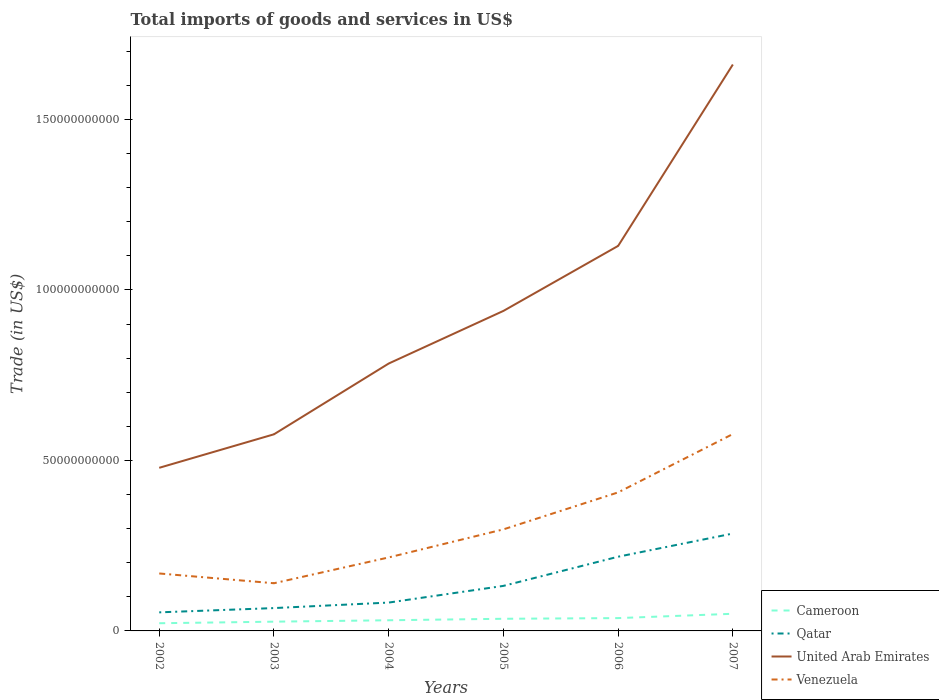How many different coloured lines are there?
Your response must be concise. 4. Is the number of lines equal to the number of legend labels?
Provide a succinct answer. Yes. Across all years, what is the maximum total imports of goods and services in Cameroon?
Your response must be concise. 2.25e+09. In which year was the total imports of goods and services in Venezuela maximum?
Offer a very short reply. 2003. What is the total total imports of goods and services in United Arab Emirates in the graph?
Your answer should be very brief. -1.91e+1. What is the difference between the highest and the second highest total imports of goods and services in Venezuela?
Provide a short and direct response. 4.38e+1. How many lines are there?
Offer a very short reply. 4. What is the difference between two consecutive major ticks on the Y-axis?
Ensure brevity in your answer.  5.00e+1. Are the values on the major ticks of Y-axis written in scientific E-notation?
Keep it short and to the point. No. Does the graph contain any zero values?
Provide a succinct answer. No. Does the graph contain grids?
Provide a succinct answer. No. How are the legend labels stacked?
Your answer should be very brief. Vertical. What is the title of the graph?
Offer a terse response. Total imports of goods and services in US$. Does "Korea (Democratic)" appear as one of the legend labels in the graph?
Ensure brevity in your answer.  No. What is the label or title of the X-axis?
Ensure brevity in your answer.  Years. What is the label or title of the Y-axis?
Offer a terse response. Trade (in US$). What is the Trade (in US$) of Cameroon in 2002?
Ensure brevity in your answer.  2.25e+09. What is the Trade (in US$) of Qatar in 2002?
Give a very brief answer. 5.45e+09. What is the Trade (in US$) in United Arab Emirates in 2002?
Give a very brief answer. 4.78e+1. What is the Trade (in US$) in Venezuela in 2002?
Your answer should be compact. 1.69e+1. What is the Trade (in US$) of Cameroon in 2003?
Offer a very short reply. 2.71e+09. What is the Trade (in US$) in Qatar in 2003?
Offer a very short reply. 6.70e+09. What is the Trade (in US$) in United Arab Emirates in 2003?
Your answer should be very brief. 5.77e+1. What is the Trade (in US$) of Venezuela in 2003?
Offer a terse response. 1.40e+1. What is the Trade (in US$) in Cameroon in 2004?
Your response must be concise. 3.13e+09. What is the Trade (in US$) of Qatar in 2004?
Provide a succinct answer. 8.32e+09. What is the Trade (in US$) of United Arab Emirates in 2004?
Ensure brevity in your answer.  7.84e+1. What is the Trade (in US$) of Venezuela in 2004?
Your answer should be very brief. 2.16e+1. What is the Trade (in US$) of Cameroon in 2005?
Offer a terse response. 3.56e+09. What is the Trade (in US$) of Qatar in 2005?
Keep it short and to the point. 1.32e+1. What is the Trade (in US$) in United Arab Emirates in 2005?
Make the answer very short. 9.39e+1. What is the Trade (in US$) of Venezuela in 2005?
Your answer should be compact. 2.98e+1. What is the Trade (in US$) of Cameroon in 2006?
Ensure brevity in your answer.  3.76e+09. What is the Trade (in US$) in Qatar in 2006?
Ensure brevity in your answer.  2.18e+1. What is the Trade (in US$) in United Arab Emirates in 2006?
Provide a succinct answer. 1.13e+11. What is the Trade (in US$) of Venezuela in 2006?
Provide a short and direct response. 4.06e+1. What is the Trade (in US$) of Cameroon in 2007?
Ensure brevity in your answer.  5.03e+09. What is the Trade (in US$) of Qatar in 2007?
Keep it short and to the point. 2.86e+1. What is the Trade (in US$) in United Arab Emirates in 2007?
Offer a terse response. 1.66e+11. What is the Trade (in US$) of Venezuela in 2007?
Your response must be concise. 5.77e+1. Across all years, what is the maximum Trade (in US$) in Cameroon?
Make the answer very short. 5.03e+09. Across all years, what is the maximum Trade (in US$) in Qatar?
Provide a short and direct response. 2.86e+1. Across all years, what is the maximum Trade (in US$) of United Arab Emirates?
Make the answer very short. 1.66e+11. Across all years, what is the maximum Trade (in US$) of Venezuela?
Your response must be concise. 5.77e+1. Across all years, what is the minimum Trade (in US$) of Cameroon?
Ensure brevity in your answer.  2.25e+09. Across all years, what is the minimum Trade (in US$) of Qatar?
Your answer should be compact. 5.45e+09. Across all years, what is the minimum Trade (in US$) in United Arab Emirates?
Keep it short and to the point. 4.78e+1. Across all years, what is the minimum Trade (in US$) of Venezuela?
Provide a short and direct response. 1.40e+1. What is the total Trade (in US$) in Cameroon in the graph?
Ensure brevity in your answer.  2.04e+1. What is the total Trade (in US$) of Qatar in the graph?
Keep it short and to the point. 8.40e+1. What is the total Trade (in US$) in United Arab Emirates in the graph?
Provide a short and direct response. 5.57e+11. What is the total Trade (in US$) of Venezuela in the graph?
Keep it short and to the point. 1.81e+11. What is the difference between the Trade (in US$) of Cameroon in 2002 and that in 2003?
Ensure brevity in your answer.  -4.58e+08. What is the difference between the Trade (in US$) of Qatar in 2002 and that in 2003?
Your answer should be compact. -1.25e+09. What is the difference between the Trade (in US$) of United Arab Emirates in 2002 and that in 2003?
Provide a succinct answer. -9.82e+09. What is the difference between the Trade (in US$) of Venezuela in 2002 and that in 2003?
Your answer should be very brief. 2.87e+09. What is the difference between the Trade (in US$) in Cameroon in 2002 and that in 2004?
Offer a terse response. -8.74e+08. What is the difference between the Trade (in US$) of Qatar in 2002 and that in 2004?
Provide a short and direct response. -2.87e+09. What is the difference between the Trade (in US$) of United Arab Emirates in 2002 and that in 2004?
Make the answer very short. -3.06e+1. What is the difference between the Trade (in US$) in Venezuela in 2002 and that in 2004?
Your answer should be compact. -4.70e+09. What is the difference between the Trade (in US$) of Cameroon in 2002 and that in 2005?
Offer a very short reply. -1.31e+09. What is the difference between the Trade (in US$) of Qatar in 2002 and that in 2005?
Make the answer very short. -7.76e+09. What is the difference between the Trade (in US$) of United Arab Emirates in 2002 and that in 2005?
Your response must be concise. -4.60e+1. What is the difference between the Trade (in US$) of Venezuela in 2002 and that in 2005?
Your answer should be very brief. -1.29e+1. What is the difference between the Trade (in US$) in Cameroon in 2002 and that in 2006?
Make the answer very short. -1.51e+09. What is the difference between the Trade (in US$) of Qatar in 2002 and that in 2006?
Your answer should be compact. -1.63e+1. What is the difference between the Trade (in US$) of United Arab Emirates in 2002 and that in 2006?
Offer a very short reply. -6.51e+1. What is the difference between the Trade (in US$) in Venezuela in 2002 and that in 2006?
Offer a terse response. -2.38e+1. What is the difference between the Trade (in US$) of Cameroon in 2002 and that in 2007?
Your answer should be very brief. -2.77e+09. What is the difference between the Trade (in US$) of Qatar in 2002 and that in 2007?
Offer a very short reply. -2.31e+1. What is the difference between the Trade (in US$) in United Arab Emirates in 2002 and that in 2007?
Give a very brief answer. -1.18e+11. What is the difference between the Trade (in US$) in Venezuela in 2002 and that in 2007?
Provide a short and direct response. -4.09e+1. What is the difference between the Trade (in US$) in Cameroon in 2003 and that in 2004?
Give a very brief answer. -4.16e+08. What is the difference between the Trade (in US$) in Qatar in 2003 and that in 2004?
Keep it short and to the point. -1.62e+09. What is the difference between the Trade (in US$) in United Arab Emirates in 2003 and that in 2004?
Your answer should be compact. -2.08e+1. What is the difference between the Trade (in US$) in Venezuela in 2003 and that in 2004?
Your answer should be compact. -7.57e+09. What is the difference between the Trade (in US$) of Cameroon in 2003 and that in 2005?
Make the answer very short. -8.49e+08. What is the difference between the Trade (in US$) of Qatar in 2003 and that in 2005?
Give a very brief answer. -6.51e+09. What is the difference between the Trade (in US$) of United Arab Emirates in 2003 and that in 2005?
Ensure brevity in your answer.  -3.62e+1. What is the difference between the Trade (in US$) in Venezuela in 2003 and that in 2005?
Make the answer very short. -1.58e+1. What is the difference between the Trade (in US$) of Cameroon in 2003 and that in 2006?
Keep it short and to the point. -1.05e+09. What is the difference between the Trade (in US$) of Qatar in 2003 and that in 2006?
Provide a short and direct response. -1.51e+1. What is the difference between the Trade (in US$) in United Arab Emirates in 2003 and that in 2006?
Ensure brevity in your answer.  -5.53e+1. What is the difference between the Trade (in US$) in Venezuela in 2003 and that in 2006?
Keep it short and to the point. -2.67e+1. What is the difference between the Trade (in US$) in Cameroon in 2003 and that in 2007?
Provide a short and direct response. -2.32e+09. What is the difference between the Trade (in US$) in Qatar in 2003 and that in 2007?
Keep it short and to the point. -2.19e+1. What is the difference between the Trade (in US$) in United Arab Emirates in 2003 and that in 2007?
Ensure brevity in your answer.  -1.08e+11. What is the difference between the Trade (in US$) of Venezuela in 2003 and that in 2007?
Your response must be concise. -4.38e+1. What is the difference between the Trade (in US$) of Cameroon in 2004 and that in 2005?
Your answer should be compact. -4.33e+08. What is the difference between the Trade (in US$) in Qatar in 2004 and that in 2005?
Make the answer very short. -4.89e+09. What is the difference between the Trade (in US$) in United Arab Emirates in 2004 and that in 2005?
Your answer should be compact. -1.54e+1. What is the difference between the Trade (in US$) of Venezuela in 2004 and that in 2005?
Your answer should be very brief. -8.23e+09. What is the difference between the Trade (in US$) in Cameroon in 2004 and that in 2006?
Keep it short and to the point. -6.33e+08. What is the difference between the Trade (in US$) in Qatar in 2004 and that in 2006?
Offer a very short reply. -1.35e+1. What is the difference between the Trade (in US$) in United Arab Emirates in 2004 and that in 2006?
Make the answer very short. -3.45e+1. What is the difference between the Trade (in US$) of Venezuela in 2004 and that in 2006?
Make the answer very short. -1.91e+1. What is the difference between the Trade (in US$) in Cameroon in 2004 and that in 2007?
Offer a terse response. -1.90e+09. What is the difference between the Trade (in US$) in Qatar in 2004 and that in 2007?
Keep it short and to the point. -2.03e+1. What is the difference between the Trade (in US$) of United Arab Emirates in 2004 and that in 2007?
Keep it short and to the point. -8.77e+1. What is the difference between the Trade (in US$) of Venezuela in 2004 and that in 2007?
Your answer should be very brief. -3.62e+1. What is the difference between the Trade (in US$) in Cameroon in 2005 and that in 2006?
Provide a short and direct response. -2.00e+08. What is the difference between the Trade (in US$) in Qatar in 2005 and that in 2006?
Your answer should be very brief. -8.56e+09. What is the difference between the Trade (in US$) in United Arab Emirates in 2005 and that in 2006?
Make the answer very short. -1.91e+1. What is the difference between the Trade (in US$) in Venezuela in 2005 and that in 2006?
Your answer should be very brief. -1.09e+1. What is the difference between the Trade (in US$) of Cameroon in 2005 and that in 2007?
Your answer should be very brief. -1.47e+09. What is the difference between the Trade (in US$) in Qatar in 2005 and that in 2007?
Offer a very short reply. -1.54e+1. What is the difference between the Trade (in US$) of United Arab Emirates in 2005 and that in 2007?
Your response must be concise. -7.23e+1. What is the difference between the Trade (in US$) of Venezuela in 2005 and that in 2007?
Offer a terse response. -2.80e+1. What is the difference between the Trade (in US$) of Cameroon in 2006 and that in 2007?
Provide a succinct answer. -1.27e+09. What is the difference between the Trade (in US$) in Qatar in 2006 and that in 2007?
Give a very brief answer. -6.80e+09. What is the difference between the Trade (in US$) in United Arab Emirates in 2006 and that in 2007?
Offer a very short reply. -5.32e+1. What is the difference between the Trade (in US$) in Venezuela in 2006 and that in 2007?
Your answer should be very brief. -1.71e+1. What is the difference between the Trade (in US$) of Cameroon in 2002 and the Trade (in US$) of Qatar in 2003?
Ensure brevity in your answer.  -4.45e+09. What is the difference between the Trade (in US$) in Cameroon in 2002 and the Trade (in US$) in United Arab Emirates in 2003?
Offer a terse response. -5.54e+1. What is the difference between the Trade (in US$) of Cameroon in 2002 and the Trade (in US$) of Venezuela in 2003?
Give a very brief answer. -1.17e+1. What is the difference between the Trade (in US$) in Qatar in 2002 and the Trade (in US$) in United Arab Emirates in 2003?
Offer a very short reply. -5.22e+1. What is the difference between the Trade (in US$) in Qatar in 2002 and the Trade (in US$) in Venezuela in 2003?
Provide a succinct answer. -8.54e+09. What is the difference between the Trade (in US$) of United Arab Emirates in 2002 and the Trade (in US$) of Venezuela in 2003?
Your answer should be very brief. 3.39e+1. What is the difference between the Trade (in US$) in Cameroon in 2002 and the Trade (in US$) in Qatar in 2004?
Provide a succinct answer. -6.06e+09. What is the difference between the Trade (in US$) in Cameroon in 2002 and the Trade (in US$) in United Arab Emirates in 2004?
Offer a terse response. -7.62e+1. What is the difference between the Trade (in US$) in Cameroon in 2002 and the Trade (in US$) in Venezuela in 2004?
Give a very brief answer. -1.93e+1. What is the difference between the Trade (in US$) in Qatar in 2002 and the Trade (in US$) in United Arab Emirates in 2004?
Your response must be concise. -7.30e+1. What is the difference between the Trade (in US$) in Qatar in 2002 and the Trade (in US$) in Venezuela in 2004?
Ensure brevity in your answer.  -1.61e+1. What is the difference between the Trade (in US$) in United Arab Emirates in 2002 and the Trade (in US$) in Venezuela in 2004?
Provide a short and direct response. 2.63e+1. What is the difference between the Trade (in US$) of Cameroon in 2002 and the Trade (in US$) of Qatar in 2005?
Make the answer very short. -1.10e+1. What is the difference between the Trade (in US$) of Cameroon in 2002 and the Trade (in US$) of United Arab Emirates in 2005?
Give a very brief answer. -9.16e+1. What is the difference between the Trade (in US$) in Cameroon in 2002 and the Trade (in US$) in Venezuela in 2005?
Keep it short and to the point. -2.75e+1. What is the difference between the Trade (in US$) in Qatar in 2002 and the Trade (in US$) in United Arab Emirates in 2005?
Make the answer very short. -8.84e+1. What is the difference between the Trade (in US$) in Qatar in 2002 and the Trade (in US$) in Venezuela in 2005?
Provide a short and direct response. -2.43e+1. What is the difference between the Trade (in US$) in United Arab Emirates in 2002 and the Trade (in US$) in Venezuela in 2005?
Offer a terse response. 1.81e+1. What is the difference between the Trade (in US$) of Cameroon in 2002 and the Trade (in US$) of Qatar in 2006?
Your response must be concise. -1.95e+1. What is the difference between the Trade (in US$) in Cameroon in 2002 and the Trade (in US$) in United Arab Emirates in 2006?
Offer a terse response. -1.11e+11. What is the difference between the Trade (in US$) of Cameroon in 2002 and the Trade (in US$) of Venezuela in 2006?
Your answer should be compact. -3.84e+1. What is the difference between the Trade (in US$) of Qatar in 2002 and the Trade (in US$) of United Arab Emirates in 2006?
Ensure brevity in your answer.  -1.07e+11. What is the difference between the Trade (in US$) of Qatar in 2002 and the Trade (in US$) of Venezuela in 2006?
Provide a succinct answer. -3.52e+1. What is the difference between the Trade (in US$) of United Arab Emirates in 2002 and the Trade (in US$) of Venezuela in 2006?
Offer a very short reply. 7.21e+09. What is the difference between the Trade (in US$) in Cameroon in 2002 and the Trade (in US$) in Qatar in 2007?
Offer a very short reply. -2.63e+1. What is the difference between the Trade (in US$) of Cameroon in 2002 and the Trade (in US$) of United Arab Emirates in 2007?
Your answer should be very brief. -1.64e+11. What is the difference between the Trade (in US$) of Cameroon in 2002 and the Trade (in US$) of Venezuela in 2007?
Offer a terse response. -5.55e+1. What is the difference between the Trade (in US$) of Qatar in 2002 and the Trade (in US$) of United Arab Emirates in 2007?
Make the answer very short. -1.61e+11. What is the difference between the Trade (in US$) of Qatar in 2002 and the Trade (in US$) of Venezuela in 2007?
Your answer should be very brief. -5.23e+1. What is the difference between the Trade (in US$) in United Arab Emirates in 2002 and the Trade (in US$) in Venezuela in 2007?
Ensure brevity in your answer.  -9.90e+09. What is the difference between the Trade (in US$) in Cameroon in 2003 and the Trade (in US$) in Qatar in 2004?
Keep it short and to the point. -5.60e+09. What is the difference between the Trade (in US$) in Cameroon in 2003 and the Trade (in US$) in United Arab Emirates in 2004?
Your answer should be very brief. -7.57e+1. What is the difference between the Trade (in US$) in Cameroon in 2003 and the Trade (in US$) in Venezuela in 2004?
Ensure brevity in your answer.  -1.88e+1. What is the difference between the Trade (in US$) of Qatar in 2003 and the Trade (in US$) of United Arab Emirates in 2004?
Provide a succinct answer. -7.17e+1. What is the difference between the Trade (in US$) in Qatar in 2003 and the Trade (in US$) in Venezuela in 2004?
Give a very brief answer. -1.49e+1. What is the difference between the Trade (in US$) of United Arab Emirates in 2003 and the Trade (in US$) of Venezuela in 2004?
Ensure brevity in your answer.  3.61e+1. What is the difference between the Trade (in US$) of Cameroon in 2003 and the Trade (in US$) of Qatar in 2005?
Your response must be concise. -1.05e+1. What is the difference between the Trade (in US$) in Cameroon in 2003 and the Trade (in US$) in United Arab Emirates in 2005?
Offer a very short reply. -9.12e+1. What is the difference between the Trade (in US$) of Cameroon in 2003 and the Trade (in US$) of Venezuela in 2005?
Keep it short and to the point. -2.71e+1. What is the difference between the Trade (in US$) of Qatar in 2003 and the Trade (in US$) of United Arab Emirates in 2005?
Your answer should be very brief. -8.72e+1. What is the difference between the Trade (in US$) in Qatar in 2003 and the Trade (in US$) in Venezuela in 2005?
Your answer should be compact. -2.31e+1. What is the difference between the Trade (in US$) in United Arab Emirates in 2003 and the Trade (in US$) in Venezuela in 2005?
Make the answer very short. 2.79e+1. What is the difference between the Trade (in US$) of Cameroon in 2003 and the Trade (in US$) of Qatar in 2006?
Make the answer very short. -1.91e+1. What is the difference between the Trade (in US$) in Cameroon in 2003 and the Trade (in US$) in United Arab Emirates in 2006?
Give a very brief answer. -1.10e+11. What is the difference between the Trade (in US$) of Cameroon in 2003 and the Trade (in US$) of Venezuela in 2006?
Your answer should be very brief. -3.79e+1. What is the difference between the Trade (in US$) of Qatar in 2003 and the Trade (in US$) of United Arab Emirates in 2006?
Make the answer very short. -1.06e+11. What is the difference between the Trade (in US$) of Qatar in 2003 and the Trade (in US$) of Venezuela in 2006?
Offer a very short reply. -3.39e+1. What is the difference between the Trade (in US$) of United Arab Emirates in 2003 and the Trade (in US$) of Venezuela in 2006?
Make the answer very short. 1.70e+1. What is the difference between the Trade (in US$) in Cameroon in 2003 and the Trade (in US$) in Qatar in 2007?
Your answer should be compact. -2.59e+1. What is the difference between the Trade (in US$) of Cameroon in 2003 and the Trade (in US$) of United Arab Emirates in 2007?
Provide a short and direct response. -1.63e+11. What is the difference between the Trade (in US$) in Cameroon in 2003 and the Trade (in US$) in Venezuela in 2007?
Your answer should be very brief. -5.50e+1. What is the difference between the Trade (in US$) in Qatar in 2003 and the Trade (in US$) in United Arab Emirates in 2007?
Your answer should be compact. -1.59e+11. What is the difference between the Trade (in US$) of Qatar in 2003 and the Trade (in US$) of Venezuela in 2007?
Provide a succinct answer. -5.10e+1. What is the difference between the Trade (in US$) of United Arab Emirates in 2003 and the Trade (in US$) of Venezuela in 2007?
Keep it short and to the point. -8.09e+07. What is the difference between the Trade (in US$) in Cameroon in 2004 and the Trade (in US$) in Qatar in 2005?
Your answer should be very brief. -1.01e+1. What is the difference between the Trade (in US$) of Cameroon in 2004 and the Trade (in US$) of United Arab Emirates in 2005?
Your answer should be compact. -9.07e+1. What is the difference between the Trade (in US$) in Cameroon in 2004 and the Trade (in US$) in Venezuela in 2005?
Offer a very short reply. -2.67e+1. What is the difference between the Trade (in US$) of Qatar in 2004 and the Trade (in US$) of United Arab Emirates in 2005?
Make the answer very short. -8.55e+1. What is the difference between the Trade (in US$) of Qatar in 2004 and the Trade (in US$) of Venezuela in 2005?
Your answer should be very brief. -2.15e+1. What is the difference between the Trade (in US$) of United Arab Emirates in 2004 and the Trade (in US$) of Venezuela in 2005?
Your answer should be very brief. 4.86e+1. What is the difference between the Trade (in US$) of Cameroon in 2004 and the Trade (in US$) of Qatar in 2006?
Give a very brief answer. -1.86e+1. What is the difference between the Trade (in US$) of Cameroon in 2004 and the Trade (in US$) of United Arab Emirates in 2006?
Provide a succinct answer. -1.10e+11. What is the difference between the Trade (in US$) of Cameroon in 2004 and the Trade (in US$) of Venezuela in 2006?
Make the answer very short. -3.75e+1. What is the difference between the Trade (in US$) of Qatar in 2004 and the Trade (in US$) of United Arab Emirates in 2006?
Offer a very short reply. -1.05e+11. What is the difference between the Trade (in US$) in Qatar in 2004 and the Trade (in US$) in Venezuela in 2006?
Your answer should be very brief. -3.23e+1. What is the difference between the Trade (in US$) in United Arab Emirates in 2004 and the Trade (in US$) in Venezuela in 2006?
Offer a terse response. 3.78e+1. What is the difference between the Trade (in US$) of Cameroon in 2004 and the Trade (in US$) of Qatar in 2007?
Ensure brevity in your answer.  -2.54e+1. What is the difference between the Trade (in US$) in Cameroon in 2004 and the Trade (in US$) in United Arab Emirates in 2007?
Provide a succinct answer. -1.63e+11. What is the difference between the Trade (in US$) of Cameroon in 2004 and the Trade (in US$) of Venezuela in 2007?
Ensure brevity in your answer.  -5.46e+1. What is the difference between the Trade (in US$) in Qatar in 2004 and the Trade (in US$) in United Arab Emirates in 2007?
Your answer should be very brief. -1.58e+11. What is the difference between the Trade (in US$) in Qatar in 2004 and the Trade (in US$) in Venezuela in 2007?
Ensure brevity in your answer.  -4.94e+1. What is the difference between the Trade (in US$) in United Arab Emirates in 2004 and the Trade (in US$) in Venezuela in 2007?
Keep it short and to the point. 2.07e+1. What is the difference between the Trade (in US$) of Cameroon in 2005 and the Trade (in US$) of Qatar in 2006?
Give a very brief answer. -1.82e+1. What is the difference between the Trade (in US$) in Cameroon in 2005 and the Trade (in US$) in United Arab Emirates in 2006?
Make the answer very short. -1.09e+11. What is the difference between the Trade (in US$) of Cameroon in 2005 and the Trade (in US$) of Venezuela in 2006?
Provide a short and direct response. -3.71e+1. What is the difference between the Trade (in US$) in Qatar in 2005 and the Trade (in US$) in United Arab Emirates in 2006?
Keep it short and to the point. -9.97e+1. What is the difference between the Trade (in US$) of Qatar in 2005 and the Trade (in US$) of Venezuela in 2006?
Make the answer very short. -2.74e+1. What is the difference between the Trade (in US$) of United Arab Emirates in 2005 and the Trade (in US$) of Venezuela in 2006?
Ensure brevity in your answer.  5.32e+1. What is the difference between the Trade (in US$) of Cameroon in 2005 and the Trade (in US$) of Qatar in 2007?
Offer a terse response. -2.50e+1. What is the difference between the Trade (in US$) in Cameroon in 2005 and the Trade (in US$) in United Arab Emirates in 2007?
Your answer should be compact. -1.63e+11. What is the difference between the Trade (in US$) of Cameroon in 2005 and the Trade (in US$) of Venezuela in 2007?
Offer a very short reply. -5.42e+1. What is the difference between the Trade (in US$) in Qatar in 2005 and the Trade (in US$) in United Arab Emirates in 2007?
Offer a terse response. -1.53e+11. What is the difference between the Trade (in US$) in Qatar in 2005 and the Trade (in US$) in Venezuela in 2007?
Ensure brevity in your answer.  -4.45e+1. What is the difference between the Trade (in US$) of United Arab Emirates in 2005 and the Trade (in US$) of Venezuela in 2007?
Keep it short and to the point. 3.61e+1. What is the difference between the Trade (in US$) in Cameroon in 2006 and the Trade (in US$) in Qatar in 2007?
Ensure brevity in your answer.  -2.48e+1. What is the difference between the Trade (in US$) of Cameroon in 2006 and the Trade (in US$) of United Arab Emirates in 2007?
Give a very brief answer. -1.62e+11. What is the difference between the Trade (in US$) in Cameroon in 2006 and the Trade (in US$) in Venezuela in 2007?
Give a very brief answer. -5.40e+1. What is the difference between the Trade (in US$) in Qatar in 2006 and the Trade (in US$) in United Arab Emirates in 2007?
Give a very brief answer. -1.44e+11. What is the difference between the Trade (in US$) of Qatar in 2006 and the Trade (in US$) of Venezuela in 2007?
Your response must be concise. -3.60e+1. What is the difference between the Trade (in US$) in United Arab Emirates in 2006 and the Trade (in US$) in Venezuela in 2007?
Keep it short and to the point. 5.52e+1. What is the average Trade (in US$) in Cameroon per year?
Keep it short and to the point. 3.41e+09. What is the average Trade (in US$) of Qatar per year?
Your response must be concise. 1.40e+1. What is the average Trade (in US$) in United Arab Emirates per year?
Your response must be concise. 9.28e+1. What is the average Trade (in US$) in Venezuela per year?
Your answer should be compact. 3.01e+1. In the year 2002, what is the difference between the Trade (in US$) in Cameroon and Trade (in US$) in Qatar?
Provide a short and direct response. -3.19e+09. In the year 2002, what is the difference between the Trade (in US$) of Cameroon and Trade (in US$) of United Arab Emirates?
Keep it short and to the point. -4.56e+1. In the year 2002, what is the difference between the Trade (in US$) of Cameroon and Trade (in US$) of Venezuela?
Offer a terse response. -1.46e+1. In the year 2002, what is the difference between the Trade (in US$) in Qatar and Trade (in US$) in United Arab Emirates?
Give a very brief answer. -4.24e+1. In the year 2002, what is the difference between the Trade (in US$) of Qatar and Trade (in US$) of Venezuela?
Make the answer very short. -1.14e+1. In the year 2002, what is the difference between the Trade (in US$) in United Arab Emirates and Trade (in US$) in Venezuela?
Make the answer very short. 3.10e+1. In the year 2003, what is the difference between the Trade (in US$) of Cameroon and Trade (in US$) of Qatar?
Your response must be concise. -3.99e+09. In the year 2003, what is the difference between the Trade (in US$) in Cameroon and Trade (in US$) in United Arab Emirates?
Provide a succinct answer. -5.50e+1. In the year 2003, what is the difference between the Trade (in US$) of Cameroon and Trade (in US$) of Venezuela?
Offer a terse response. -1.13e+1. In the year 2003, what is the difference between the Trade (in US$) in Qatar and Trade (in US$) in United Arab Emirates?
Provide a short and direct response. -5.10e+1. In the year 2003, what is the difference between the Trade (in US$) of Qatar and Trade (in US$) of Venezuela?
Offer a very short reply. -7.29e+09. In the year 2003, what is the difference between the Trade (in US$) in United Arab Emirates and Trade (in US$) in Venezuela?
Ensure brevity in your answer.  4.37e+1. In the year 2004, what is the difference between the Trade (in US$) of Cameroon and Trade (in US$) of Qatar?
Offer a very short reply. -5.19e+09. In the year 2004, what is the difference between the Trade (in US$) of Cameroon and Trade (in US$) of United Arab Emirates?
Provide a short and direct response. -7.53e+1. In the year 2004, what is the difference between the Trade (in US$) of Cameroon and Trade (in US$) of Venezuela?
Offer a very short reply. -1.84e+1. In the year 2004, what is the difference between the Trade (in US$) in Qatar and Trade (in US$) in United Arab Emirates?
Give a very brief answer. -7.01e+1. In the year 2004, what is the difference between the Trade (in US$) in Qatar and Trade (in US$) in Venezuela?
Offer a very short reply. -1.32e+1. In the year 2004, what is the difference between the Trade (in US$) in United Arab Emirates and Trade (in US$) in Venezuela?
Provide a succinct answer. 5.69e+1. In the year 2005, what is the difference between the Trade (in US$) in Cameroon and Trade (in US$) in Qatar?
Give a very brief answer. -9.65e+09. In the year 2005, what is the difference between the Trade (in US$) of Cameroon and Trade (in US$) of United Arab Emirates?
Ensure brevity in your answer.  -9.03e+1. In the year 2005, what is the difference between the Trade (in US$) in Cameroon and Trade (in US$) in Venezuela?
Provide a short and direct response. -2.62e+1. In the year 2005, what is the difference between the Trade (in US$) of Qatar and Trade (in US$) of United Arab Emirates?
Your answer should be very brief. -8.07e+1. In the year 2005, what is the difference between the Trade (in US$) of Qatar and Trade (in US$) of Venezuela?
Give a very brief answer. -1.66e+1. In the year 2005, what is the difference between the Trade (in US$) of United Arab Emirates and Trade (in US$) of Venezuela?
Provide a short and direct response. 6.41e+1. In the year 2006, what is the difference between the Trade (in US$) in Cameroon and Trade (in US$) in Qatar?
Provide a short and direct response. -1.80e+1. In the year 2006, what is the difference between the Trade (in US$) of Cameroon and Trade (in US$) of United Arab Emirates?
Keep it short and to the point. -1.09e+11. In the year 2006, what is the difference between the Trade (in US$) in Cameroon and Trade (in US$) in Venezuela?
Offer a terse response. -3.69e+1. In the year 2006, what is the difference between the Trade (in US$) in Qatar and Trade (in US$) in United Arab Emirates?
Your answer should be very brief. -9.12e+1. In the year 2006, what is the difference between the Trade (in US$) of Qatar and Trade (in US$) of Venezuela?
Give a very brief answer. -1.89e+1. In the year 2006, what is the difference between the Trade (in US$) in United Arab Emirates and Trade (in US$) in Venezuela?
Keep it short and to the point. 7.23e+1. In the year 2007, what is the difference between the Trade (in US$) in Cameroon and Trade (in US$) in Qatar?
Offer a terse response. -2.35e+1. In the year 2007, what is the difference between the Trade (in US$) of Cameroon and Trade (in US$) of United Arab Emirates?
Ensure brevity in your answer.  -1.61e+11. In the year 2007, what is the difference between the Trade (in US$) in Cameroon and Trade (in US$) in Venezuela?
Provide a short and direct response. -5.27e+1. In the year 2007, what is the difference between the Trade (in US$) in Qatar and Trade (in US$) in United Arab Emirates?
Make the answer very short. -1.38e+11. In the year 2007, what is the difference between the Trade (in US$) in Qatar and Trade (in US$) in Venezuela?
Your answer should be very brief. -2.92e+1. In the year 2007, what is the difference between the Trade (in US$) of United Arab Emirates and Trade (in US$) of Venezuela?
Your response must be concise. 1.08e+11. What is the ratio of the Trade (in US$) in Cameroon in 2002 to that in 2003?
Offer a terse response. 0.83. What is the ratio of the Trade (in US$) in Qatar in 2002 to that in 2003?
Your response must be concise. 0.81. What is the ratio of the Trade (in US$) of United Arab Emirates in 2002 to that in 2003?
Give a very brief answer. 0.83. What is the ratio of the Trade (in US$) in Venezuela in 2002 to that in 2003?
Offer a very short reply. 1.21. What is the ratio of the Trade (in US$) in Cameroon in 2002 to that in 2004?
Make the answer very short. 0.72. What is the ratio of the Trade (in US$) of Qatar in 2002 to that in 2004?
Keep it short and to the point. 0.66. What is the ratio of the Trade (in US$) in United Arab Emirates in 2002 to that in 2004?
Give a very brief answer. 0.61. What is the ratio of the Trade (in US$) in Venezuela in 2002 to that in 2004?
Make the answer very short. 0.78. What is the ratio of the Trade (in US$) of Cameroon in 2002 to that in 2005?
Offer a very short reply. 0.63. What is the ratio of the Trade (in US$) of Qatar in 2002 to that in 2005?
Your response must be concise. 0.41. What is the ratio of the Trade (in US$) in United Arab Emirates in 2002 to that in 2005?
Make the answer very short. 0.51. What is the ratio of the Trade (in US$) of Venezuela in 2002 to that in 2005?
Your answer should be very brief. 0.57. What is the ratio of the Trade (in US$) in Cameroon in 2002 to that in 2006?
Your response must be concise. 0.6. What is the ratio of the Trade (in US$) in Qatar in 2002 to that in 2006?
Your answer should be compact. 0.25. What is the ratio of the Trade (in US$) in United Arab Emirates in 2002 to that in 2006?
Make the answer very short. 0.42. What is the ratio of the Trade (in US$) of Venezuela in 2002 to that in 2006?
Offer a terse response. 0.41. What is the ratio of the Trade (in US$) in Cameroon in 2002 to that in 2007?
Offer a terse response. 0.45. What is the ratio of the Trade (in US$) of Qatar in 2002 to that in 2007?
Your answer should be very brief. 0.19. What is the ratio of the Trade (in US$) of United Arab Emirates in 2002 to that in 2007?
Provide a short and direct response. 0.29. What is the ratio of the Trade (in US$) of Venezuela in 2002 to that in 2007?
Keep it short and to the point. 0.29. What is the ratio of the Trade (in US$) in Cameroon in 2003 to that in 2004?
Ensure brevity in your answer.  0.87. What is the ratio of the Trade (in US$) in Qatar in 2003 to that in 2004?
Your response must be concise. 0.81. What is the ratio of the Trade (in US$) in United Arab Emirates in 2003 to that in 2004?
Provide a succinct answer. 0.74. What is the ratio of the Trade (in US$) in Venezuela in 2003 to that in 2004?
Give a very brief answer. 0.65. What is the ratio of the Trade (in US$) of Cameroon in 2003 to that in 2005?
Ensure brevity in your answer.  0.76. What is the ratio of the Trade (in US$) of Qatar in 2003 to that in 2005?
Ensure brevity in your answer.  0.51. What is the ratio of the Trade (in US$) of United Arab Emirates in 2003 to that in 2005?
Make the answer very short. 0.61. What is the ratio of the Trade (in US$) of Venezuela in 2003 to that in 2005?
Keep it short and to the point. 0.47. What is the ratio of the Trade (in US$) of Cameroon in 2003 to that in 2006?
Your response must be concise. 0.72. What is the ratio of the Trade (in US$) in Qatar in 2003 to that in 2006?
Give a very brief answer. 0.31. What is the ratio of the Trade (in US$) of United Arab Emirates in 2003 to that in 2006?
Provide a succinct answer. 0.51. What is the ratio of the Trade (in US$) in Venezuela in 2003 to that in 2006?
Keep it short and to the point. 0.34. What is the ratio of the Trade (in US$) in Cameroon in 2003 to that in 2007?
Make the answer very short. 0.54. What is the ratio of the Trade (in US$) of Qatar in 2003 to that in 2007?
Your response must be concise. 0.23. What is the ratio of the Trade (in US$) of United Arab Emirates in 2003 to that in 2007?
Make the answer very short. 0.35. What is the ratio of the Trade (in US$) of Venezuela in 2003 to that in 2007?
Your answer should be very brief. 0.24. What is the ratio of the Trade (in US$) in Cameroon in 2004 to that in 2005?
Make the answer very short. 0.88. What is the ratio of the Trade (in US$) of Qatar in 2004 to that in 2005?
Provide a short and direct response. 0.63. What is the ratio of the Trade (in US$) in United Arab Emirates in 2004 to that in 2005?
Your answer should be compact. 0.84. What is the ratio of the Trade (in US$) of Venezuela in 2004 to that in 2005?
Offer a terse response. 0.72. What is the ratio of the Trade (in US$) of Cameroon in 2004 to that in 2006?
Provide a short and direct response. 0.83. What is the ratio of the Trade (in US$) in Qatar in 2004 to that in 2006?
Provide a short and direct response. 0.38. What is the ratio of the Trade (in US$) in United Arab Emirates in 2004 to that in 2006?
Offer a very short reply. 0.69. What is the ratio of the Trade (in US$) of Venezuela in 2004 to that in 2006?
Your answer should be compact. 0.53. What is the ratio of the Trade (in US$) of Cameroon in 2004 to that in 2007?
Offer a terse response. 0.62. What is the ratio of the Trade (in US$) in Qatar in 2004 to that in 2007?
Offer a very short reply. 0.29. What is the ratio of the Trade (in US$) in United Arab Emirates in 2004 to that in 2007?
Your answer should be very brief. 0.47. What is the ratio of the Trade (in US$) of Venezuela in 2004 to that in 2007?
Ensure brevity in your answer.  0.37. What is the ratio of the Trade (in US$) of Cameroon in 2005 to that in 2006?
Offer a terse response. 0.95. What is the ratio of the Trade (in US$) of Qatar in 2005 to that in 2006?
Offer a terse response. 0.61. What is the ratio of the Trade (in US$) in United Arab Emirates in 2005 to that in 2006?
Offer a very short reply. 0.83. What is the ratio of the Trade (in US$) of Venezuela in 2005 to that in 2006?
Ensure brevity in your answer.  0.73. What is the ratio of the Trade (in US$) of Cameroon in 2005 to that in 2007?
Keep it short and to the point. 0.71. What is the ratio of the Trade (in US$) in Qatar in 2005 to that in 2007?
Provide a short and direct response. 0.46. What is the ratio of the Trade (in US$) of United Arab Emirates in 2005 to that in 2007?
Ensure brevity in your answer.  0.56. What is the ratio of the Trade (in US$) in Venezuela in 2005 to that in 2007?
Your answer should be compact. 0.52. What is the ratio of the Trade (in US$) of Cameroon in 2006 to that in 2007?
Your answer should be very brief. 0.75. What is the ratio of the Trade (in US$) in Qatar in 2006 to that in 2007?
Provide a short and direct response. 0.76. What is the ratio of the Trade (in US$) in United Arab Emirates in 2006 to that in 2007?
Ensure brevity in your answer.  0.68. What is the ratio of the Trade (in US$) of Venezuela in 2006 to that in 2007?
Provide a succinct answer. 0.7. What is the difference between the highest and the second highest Trade (in US$) of Cameroon?
Offer a very short reply. 1.27e+09. What is the difference between the highest and the second highest Trade (in US$) of Qatar?
Provide a short and direct response. 6.80e+09. What is the difference between the highest and the second highest Trade (in US$) of United Arab Emirates?
Give a very brief answer. 5.32e+1. What is the difference between the highest and the second highest Trade (in US$) of Venezuela?
Make the answer very short. 1.71e+1. What is the difference between the highest and the lowest Trade (in US$) of Cameroon?
Give a very brief answer. 2.77e+09. What is the difference between the highest and the lowest Trade (in US$) of Qatar?
Offer a very short reply. 2.31e+1. What is the difference between the highest and the lowest Trade (in US$) in United Arab Emirates?
Offer a very short reply. 1.18e+11. What is the difference between the highest and the lowest Trade (in US$) in Venezuela?
Provide a short and direct response. 4.38e+1. 